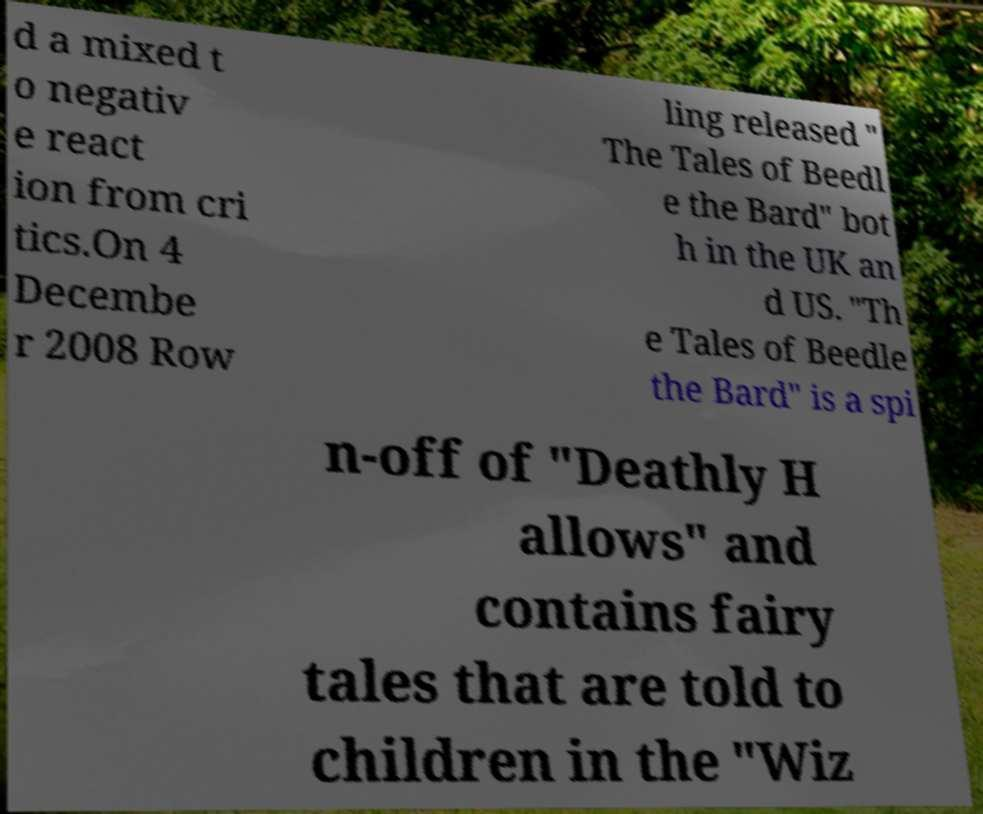What messages or text are displayed in this image? I need them in a readable, typed format. d a mixed t o negativ e react ion from cri tics.On 4 Decembe r 2008 Row ling released " The Tales of Beedl e the Bard" bot h in the UK an d US. "Th e Tales of Beedle the Bard" is a spi n-off of "Deathly H allows" and contains fairy tales that are told to children in the "Wiz 